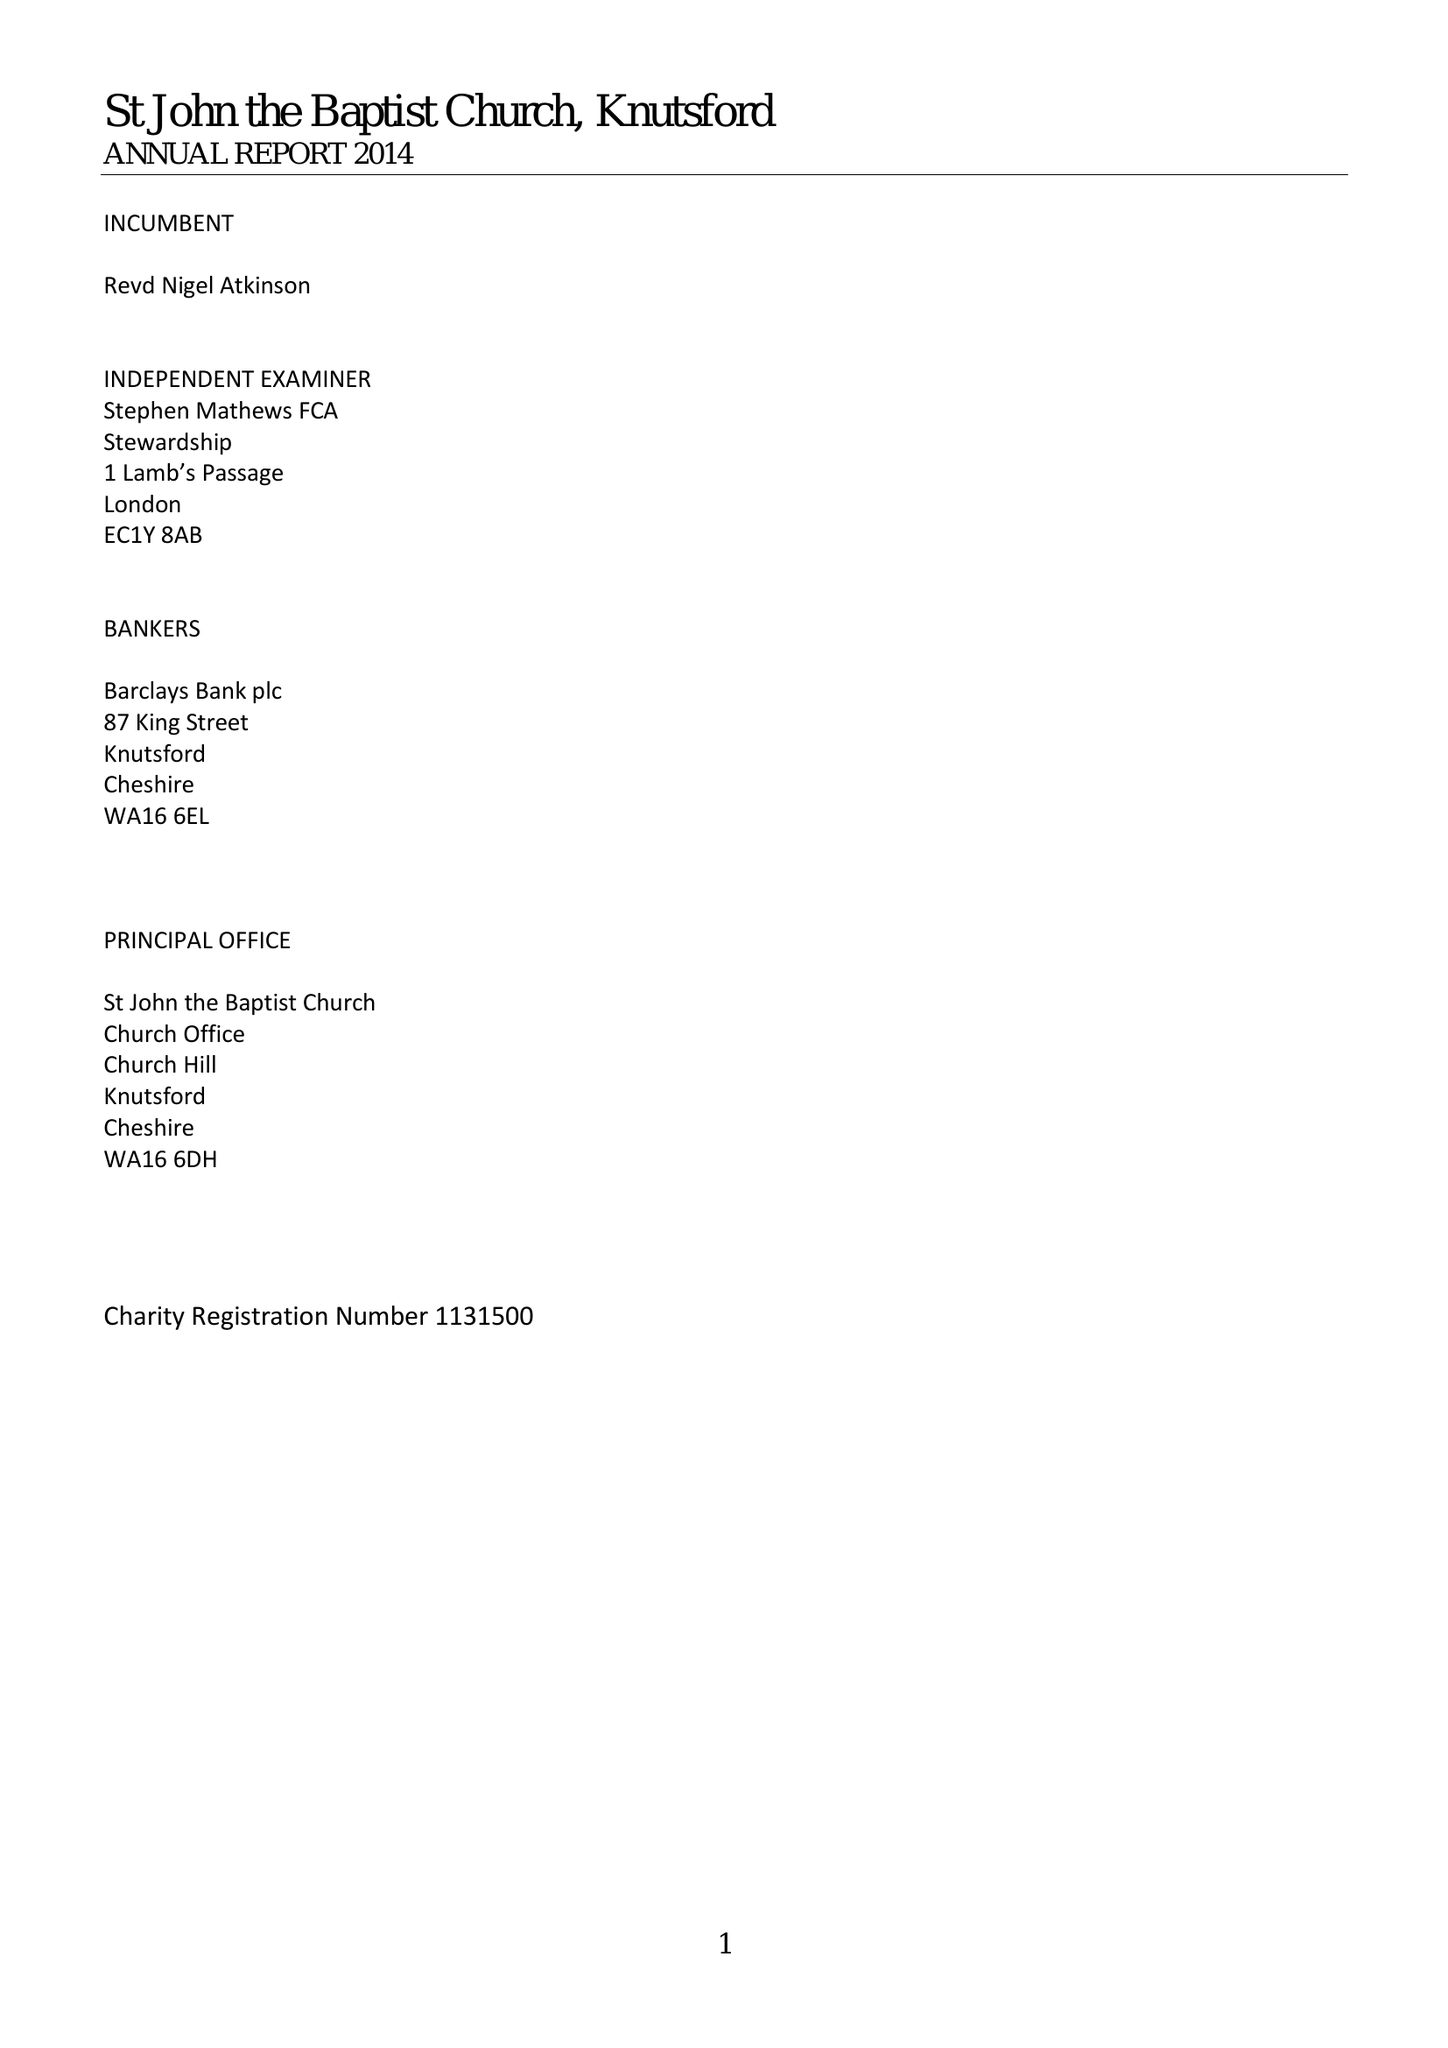What is the value for the spending_annually_in_british_pounds?
Answer the question using a single word or phrase. 690917.07 